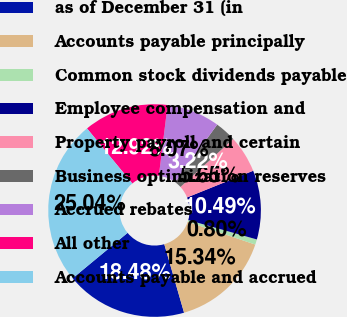Convert chart to OTSL. <chart><loc_0><loc_0><loc_500><loc_500><pie_chart><fcel>as of December 31 (in<fcel>Accounts payable principally<fcel>Common stock dividends payable<fcel>Employee compensation and<fcel>Property payroll and certain<fcel>Business optimization reserves<fcel>Accrued rebates<fcel>All other<fcel>Accounts payable and accrued<nl><fcel>18.48%<fcel>15.34%<fcel>0.8%<fcel>10.49%<fcel>5.65%<fcel>3.22%<fcel>8.07%<fcel>12.92%<fcel>25.04%<nl></chart> 